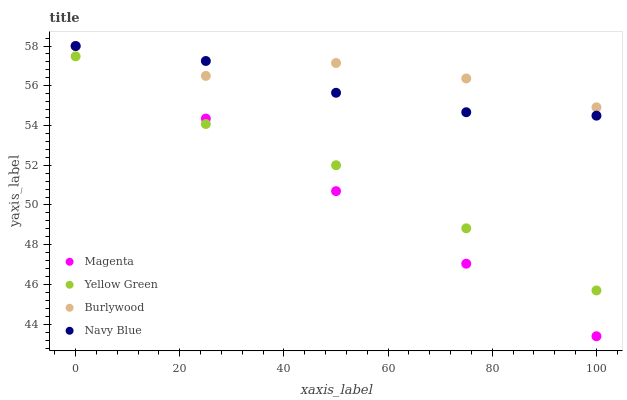Does Magenta have the minimum area under the curve?
Answer yes or no. Yes. Does Burlywood have the maximum area under the curve?
Answer yes or no. Yes. Does Navy Blue have the minimum area under the curve?
Answer yes or no. No. Does Navy Blue have the maximum area under the curve?
Answer yes or no. No. Is Magenta the smoothest?
Answer yes or no. Yes. Is Burlywood the roughest?
Answer yes or no. Yes. Is Navy Blue the smoothest?
Answer yes or no. No. Is Navy Blue the roughest?
Answer yes or no. No. Does Magenta have the lowest value?
Answer yes or no. Yes. Does Navy Blue have the lowest value?
Answer yes or no. No. Does Magenta have the highest value?
Answer yes or no. Yes. Does Yellow Green have the highest value?
Answer yes or no. No. Is Yellow Green less than Navy Blue?
Answer yes or no. Yes. Is Navy Blue greater than Yellow Green?
Answer yes or no. Yes. Does Burlywood intersect Magenta?
Answer yes or no. Yes. Is Burlywood less than Magenta?
Answer yes or no. No. Is Burlywood greater than Magenta?
Answer yes or no. No. Does Yellow Green intersect Navy Blue?
Answer yes or no. No. 